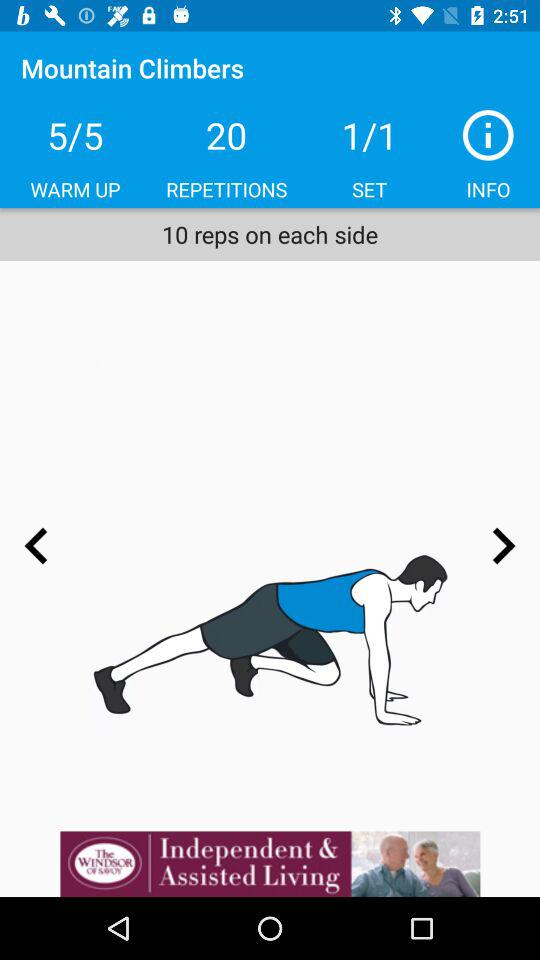How many sets are there?
Answer the question using a single word or phrase. 1 